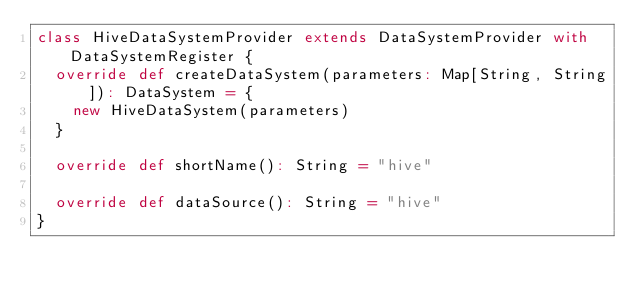<code> <loc_0><loc_0><loc_500><loc_500><_Scala_>class HiveDataSystemProvider extends DataSystemProvider with DataSystemRegister {
	override def createDataSystem(parameters: Map[String, String]): DataSystem = {
		new HiveDataSystem(parameters)
	}

	override def shortName(): String = "hive"

	override def dataSource(): String = "hive"
}
</code> 